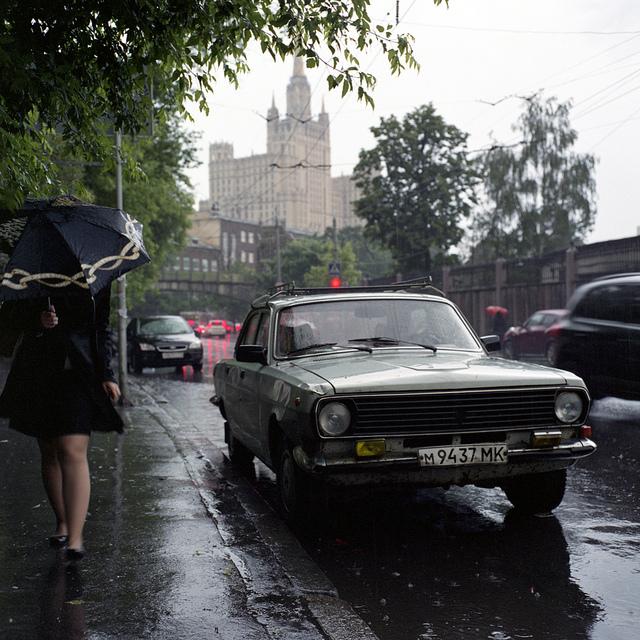What is falling from the sky?
Short answer required. Rain. What color is the car in the front on the right?
Concise answer only. Black. What does the lady in the picture probably think the temperature is?
Quick response, please. Cold. Was this photo taken in Europe?
Be succinct. Yes. What gender is the person with the umbrella?
Quick response, please. Female. 